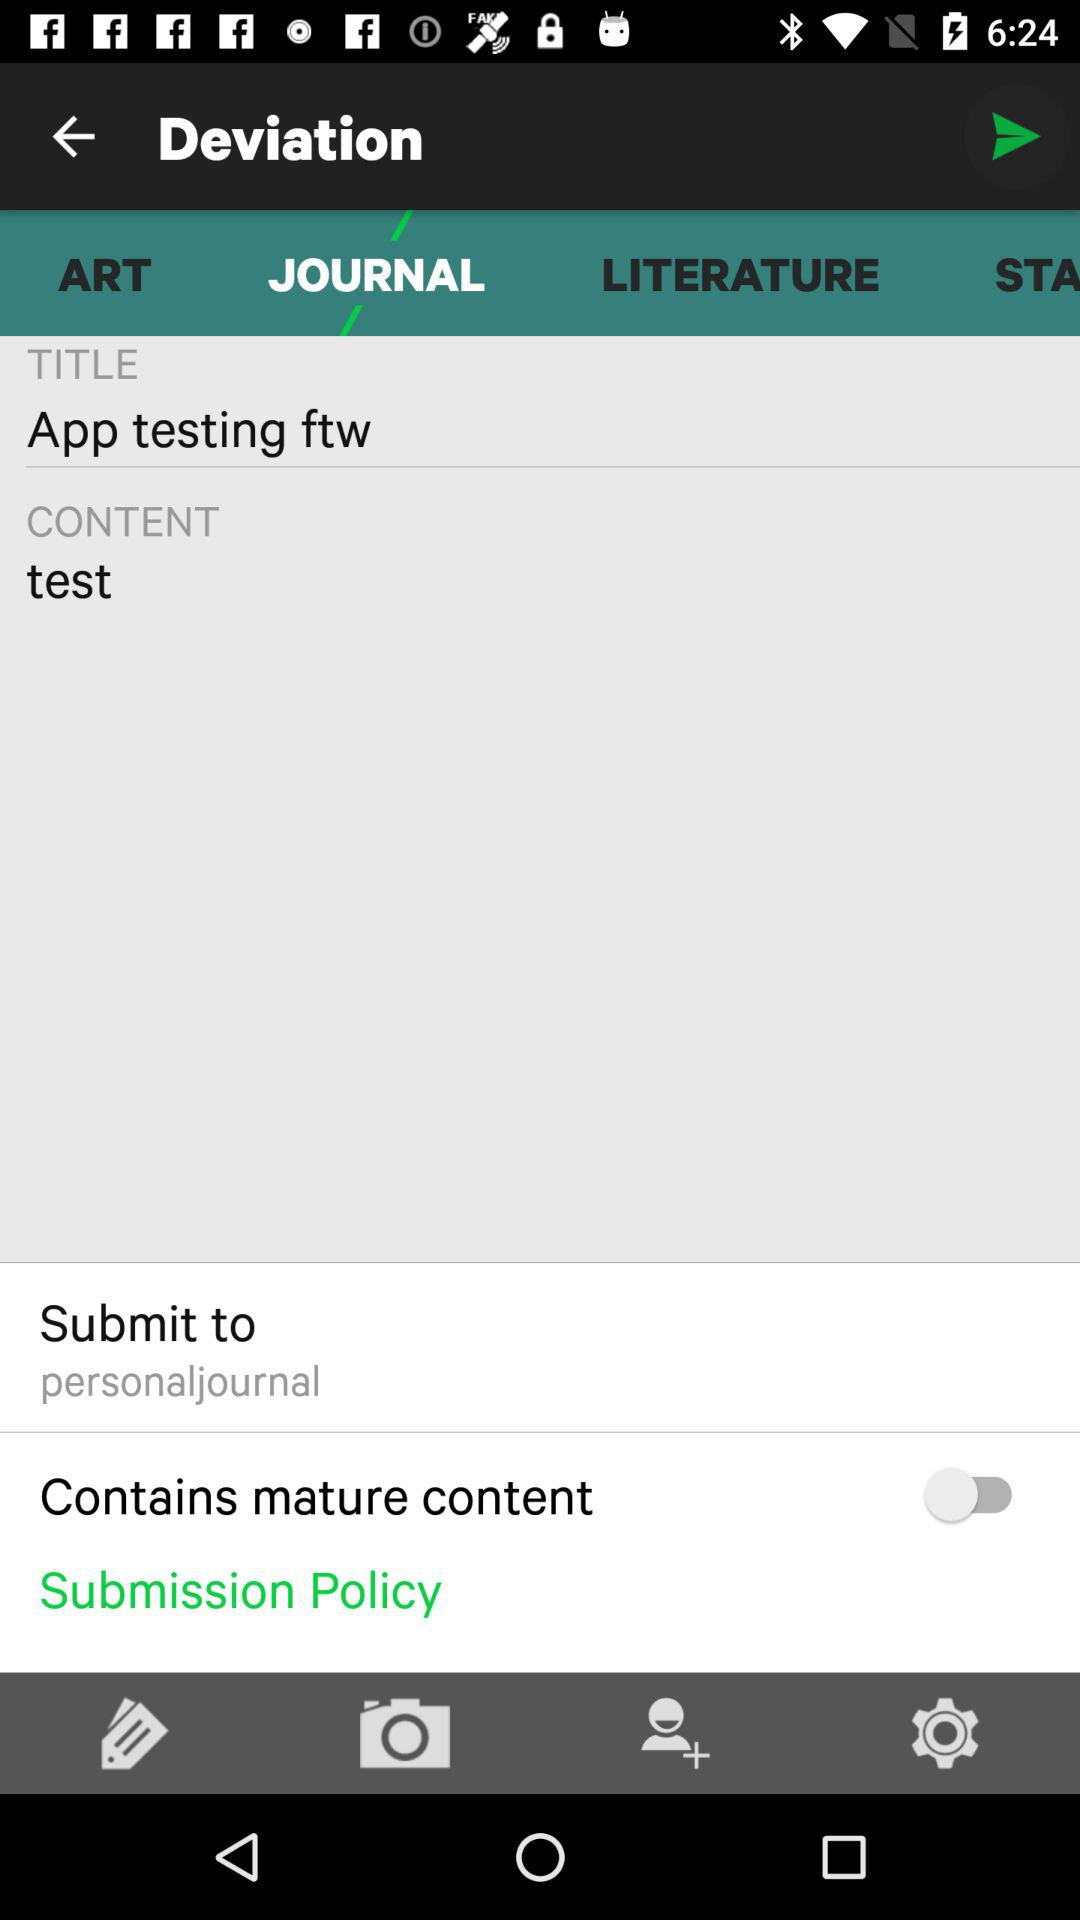What is the name of the application? The name of the application is "DEVIANT ART". 